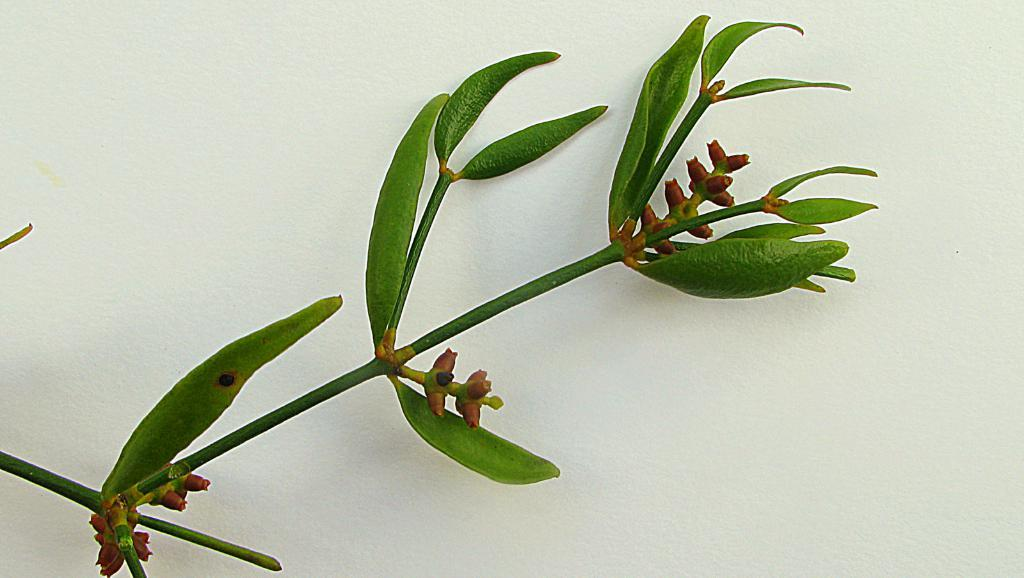What type of plant material can be seen in the image? There are leaves and a stem in the image. What is the color of the surface on which the leaves and stem are placed? There is a white surface in the image. What type of fabric is being used as fuel in the image? There is no fabric or fuel present in the image; it features leaves and a stem on a white surface. 